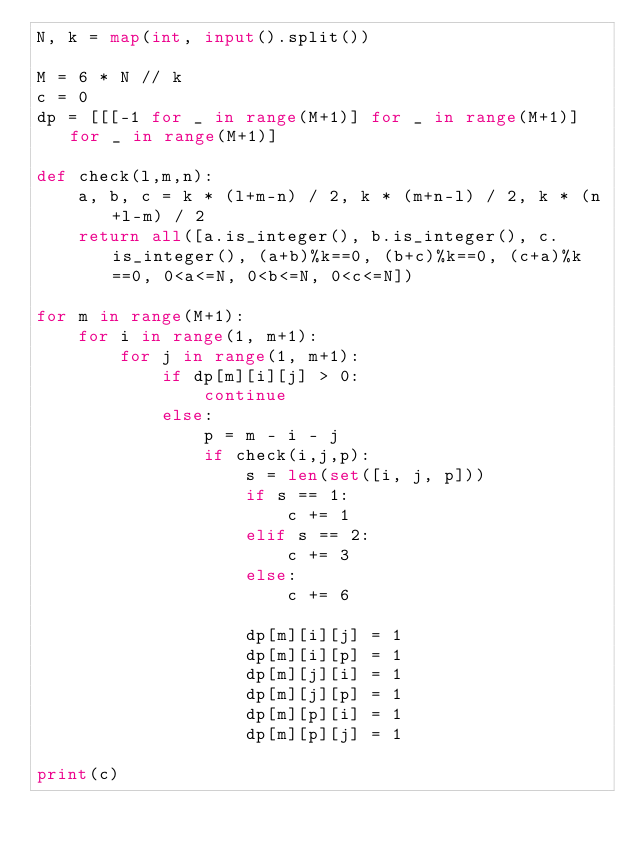Convert code to text. <code><loc_0><loc_0><loc_500><loc_500><_Python_>N, k = map(int, input().split())

M = 6 * N // k
c = 0
dp = [[[-1 for _ in range(M+1)] for _ in range(M+1)] for _ in range(M+1)]

def check(l,m,n):
    a, b, c = k * (l+m-n) / 2, k * (m+n-l) / 2, k * (n+l-m) / 2
    return all([a.is_integer(), b.is_integer(), c.is_integer(), (a+b)%k==0, (b+c)%k==0, (c+a)%k==0, 0<a<=N, 0<b<=N, 0<c<=N])

for m in range(M+1):
    for i in range(1, m+1):
        for j in range(1, m+1):
            if dp[m][i][j] > 0:
                continue
            else:
                p = m - i - j
                if check(i,j,p):
                    s = len(set([i, j, p]))
                    if s == 1:
                        c += 1
                    elif s == 2:
                        c += 3
                    else:
                        c += 6

                    dp[m][i][j] = 1
                    dp[m][i][p] = 1
                    dp[m][j][i] = 1
                    dp[m][j][p] = 1
                    dp[m][p][i] = 1
                    dp[m][p][j] = 1

print(c)
</code> 